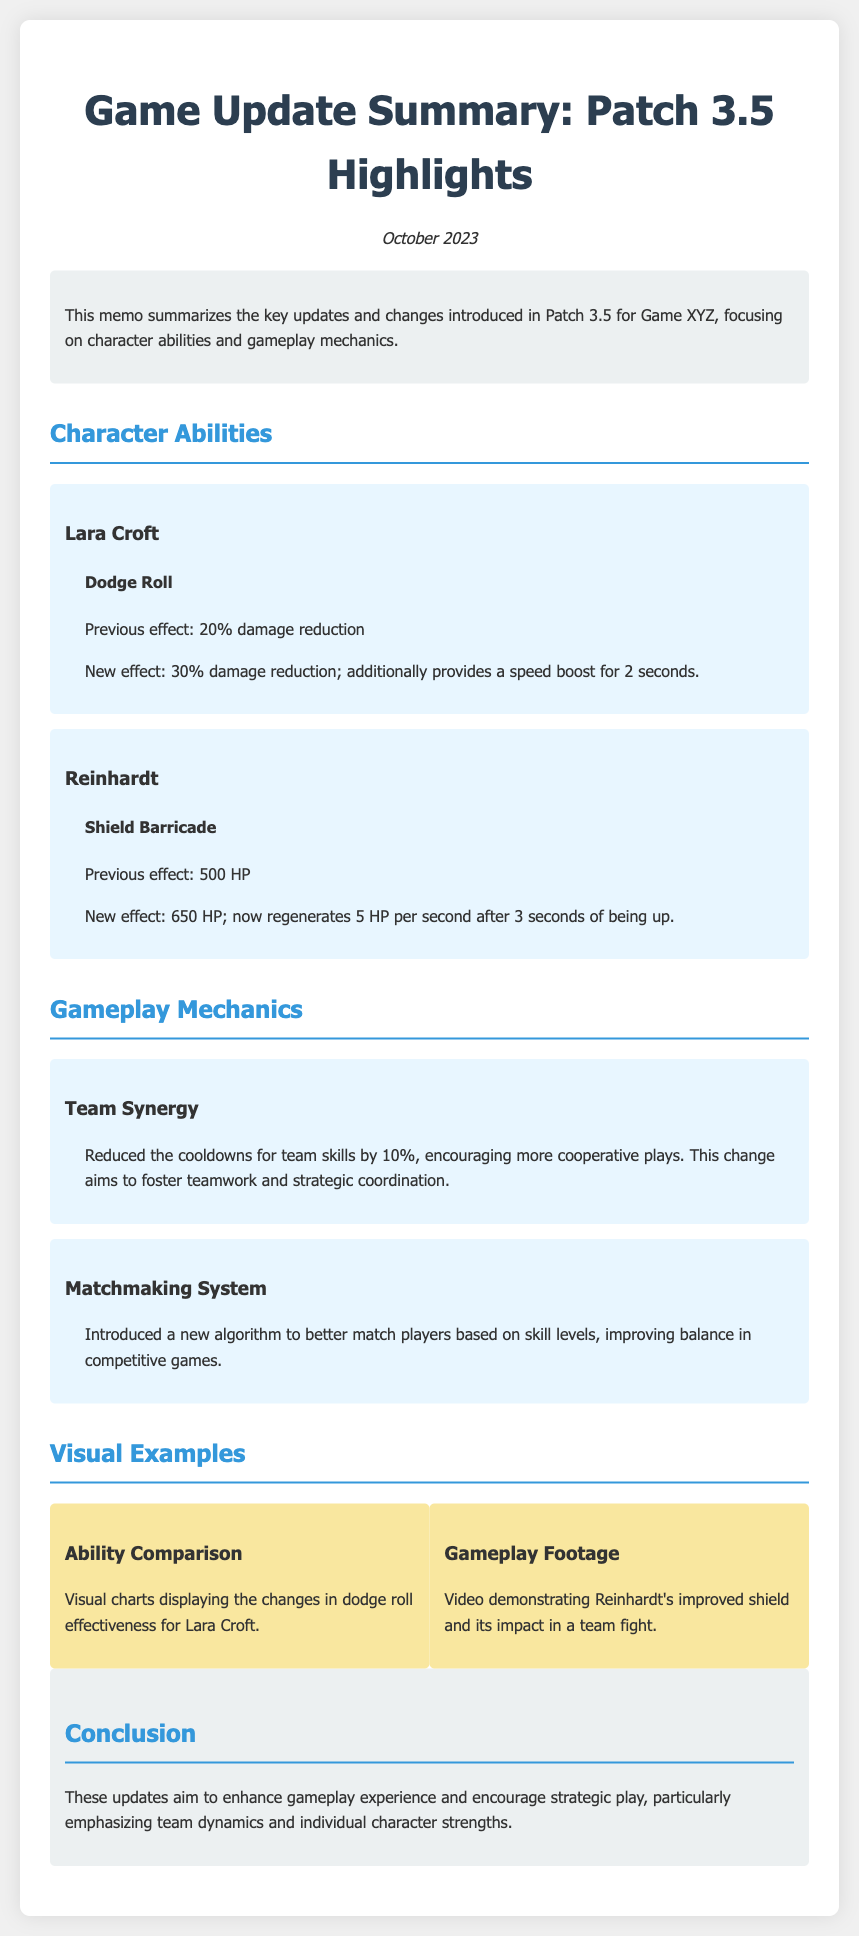What is the title of the memo? The title of the memo is the heading of the document which summarizes the key updates and changes introduced in Patch 3.5 for Game XYZ.
Answer: Game Update Summary: Patch 3.5 Highlights What is Lara Croft’s new dodge roll effect? The new effect is specified in the character abilities section of the memo.
Answer: 30% damage reduction; additionally provides a speed boost for 2 seconds What is Reinhardt's shield health after the update? The updated health of Reinhardt's shield is mentioned under character abilities in the document.
Answer: 650 HP What change was made to team synergy? The document describes updates in gameplay mechanics, including specifics on team synergy improvements.
Answer: Reduced the cooldowns for team skills by 10% What new feature was introduced in the matchmaking system? Information on the new algorithm can be found in the gameplay mechanics section of the memo.
Answer: A new algorithm to better match players based on skill levels What type of visual example demonstrates Reinhardt's improved shield? The memo lists the types of visual examples presented for clarity and understanding.
Answer: Video demonstrating Reinhardt's improved shield and its impact in a team fight How often does Reinhardt’s shield regenerate after being up? The regeneration rate is detailed in the character abilities section.
Answer: 5 HP per second after 3 seconds What date was the memo published? The date is presented at the top of the memo, providing a clear timeline for the updates.
Answer: October 2023 